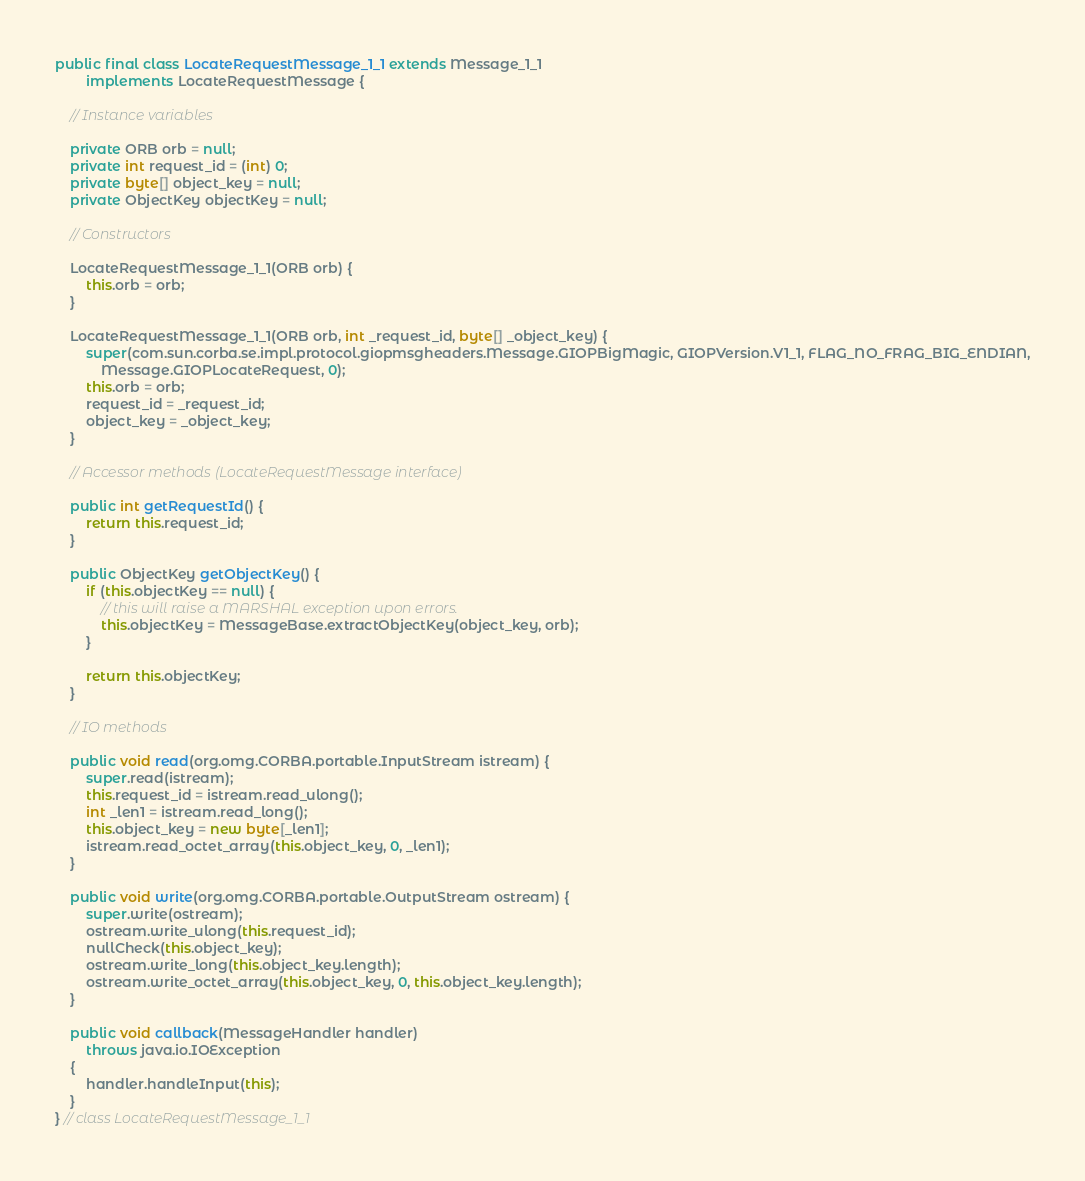<code> <loc_0><loc_0><loc_500><loc_500><_Java_>
public final class LocateRequestMessage_1_1 extends Message_1_1
        implements LocateRequestMessage {

    // Instance variables

    private ORB orb = null;
    private int request_id = (int) 0;
    private byte[] object_key = null;
    private ObjectKey objectKey = null;

    // Constructors

    LocateRequestMessage_1_1(ORB orb) {
        this.orb = orb;
    }

    LocateRequestMessage_1_1(ORB orb, int _request_id, byte[] _object_key) {
        super(com.sun.corba.se.impl.protocol.giopmsgheaders.Message.GIOPBigMagic, GIOPVersion.V1_1, FLAG_NO_FRAG_BIG_ENDIAN,
            Message.GIOPLocateRequest, 0);
        this.orb = orb;
        request_id = _request_id;
        object_key = _object_key;
    }

    // Accessor methods (LocateRequestMessage interface)

    public int getRequestId() {
        return this.request_id;
    }

    public ObjectKey getObjectKey() {
        if (this.objectKey == null) {
            // this will raise a MARSHAL exception upon errors.
            this.objectKey = MessageBase.extractObjectKey(object_key, orb);
        }

        return this.objectKey;
    }

    // IO methods

    public void read(org.omg.CORBA.portable.InputStream istream) {
        super.read(istream);
        this.request_id = istream.read_ulong();
        int _len1 = istream.read_long();
        this.object_key = new byte[_len1];
        istream.read_octet_array(this.object_key, 0, _len1);
    }

    public void write(org.omg.CORBA.portable.OutputStream ostream) {
        super.write(ostream);
        ostream.write_ulong(this.request_id);
        nullCheck(this.object_key);
        ostream.write_long(this.object_key.length);
        ostream.write_octet_array(this.object_key, 0, this.object_key.length);
    }

    public void callback(MessageHandler handler)
        throws java.io.IOException
    {
        handler.handleInput(this);
    }
} // class LocateRequestMessage_1_1
</code> 